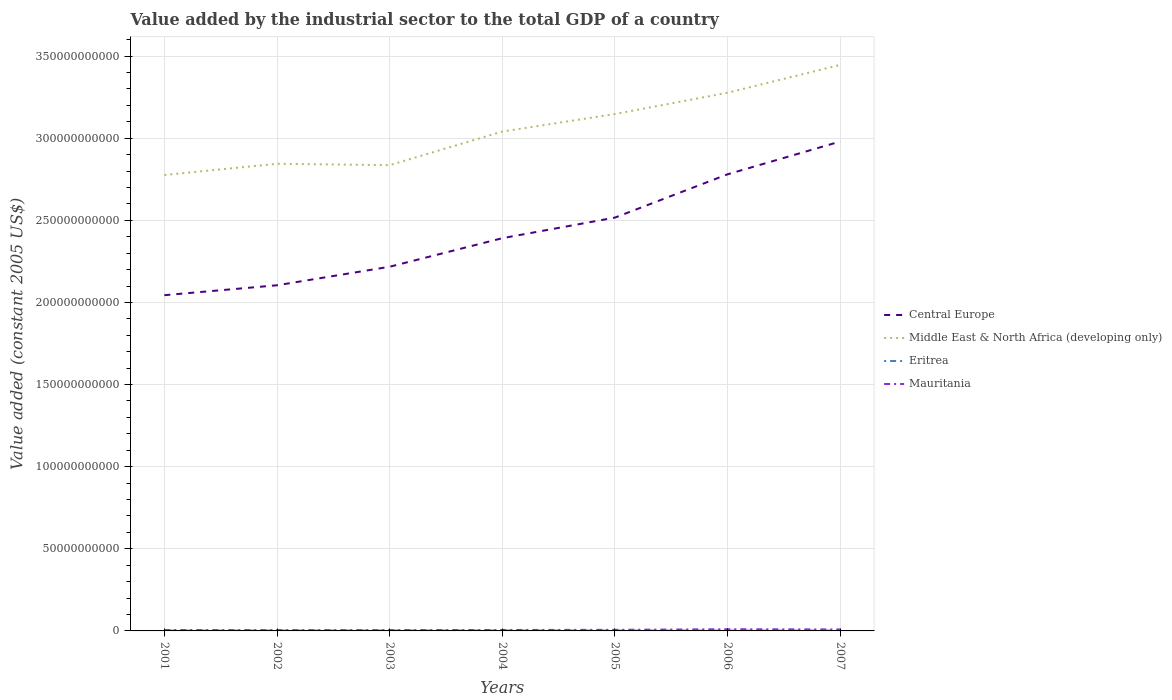Does the line corresponding to Middle East & North Africa (developing only) intersect with the line corresponding to Mauritania?
Offer a terse response. No. Across all years, what is the maximum value added by the industrial sector in Central Europe?
Your response must be concise. 2.04e+11. In which year was the value added by the industrial sector in Eritrea maximum?
Provide a short and direct response. 2001. What is the total value added by the industrial sector in Middle East & North Africa (developing only) in the graph?
Ensure brevity in your answer.  8.50e+08. What is the difference between the highest and the second highest value added by the industrial sector in Central Europe?
Give a very brief answer. 9.36e+1. What is the difference between the highest and the lowest value added by the industrial sector in Eritrea?
Ensure brevity in your answer.  3. How many years are there in the graph?
Ensure brevity in your answer.  7. Does the graph contain any zero values?
Offer a very short reply. No. Does the graph contain grids?
Ensure brevity in your answer.  Yes. How many legend labels are there?
Give a very brief answer. 4. How are the legend labels stacked?
Your answer should be very brief. Vertical. What is the title of the graph?
Offer a terse response. Value added by the industrial sector to the total GDP of a country. What is the label or title of the X-axis?
Your response must be concise. Years. What is the label or title of the Y-axis?
Your answer should be very brief. Value added (constant 2005 US$). What is the Value added (constant 2005 US$) of Central Europe in 2001?
Offer a terse response. 2.04e+11. What is the Value added (constant 2005 US$) of Middle East & North Africa (developing only) in 2001?
Provide a short and direct response. 2.78e+11. What is the Value added (constant 2005 US$) of Eritrea in 2001?
Keep it short and to the point. 1.92e+08. What is the Value added (constant 2005 US$) of Mauritania in 2001?
Provide a succinct answer. 5.36e+08. What is the Value added (constant 2005 US$) in Central Europe in 2002?
Provide a short and direct response. 2.10e+11. What is the Value added (constant 2005 US$) in Middle East & North Africa (developing only) in 2002?
Provide a succinct answer. 2.84e+11. What is the Value added (constant 2005 US$) in Eritrea in 2002?
Offer a terse response. 2.08e+08. What is the Value added (constant 2005 US$) in Mauritania in 2002?
Provide a short and direct response. 4.98e+08. What is the Value added (constant 2005 US$) of Central Europe in 2003?
Ensure brevity in your answer.  2.22e+11. What is the Value added (constant 2005 US$) in Middle East & North Africa (developing only) in 2003?
Your answer should be compact. 2.84e+11. What is the Value added (constant 2005 US$) in Eritrea in 2003?
Keep it short and to the point. 2.36e+08. What is the Value added (constant 2005 US$) in Mauritania in 2003?
Your answer should be compact. 5.08e+08. What is the Value added (constant 2005 US$) in Central Europe in 2004?
Provide a succinct answer. 2.39e+11. What is the Value added (constant 2005 US$) in Middle East & North Africa (developing only) in 2004?
Offer a very short reply. 3.04e+11. What is the Value added (constant 2005 US$) in Eritrea in 2004?
Keep it short and to the point. 2.47e+08. What is the Value added (constant 2005 US$) in Mauritania in 2004?
Provide a succinct answer. 5.74e+08. What is the Value added (constant 2005 US$) in Central Europe in 2005?
Offer a terse response. 2.52e+11. What is the Value added (constant 2005 US$) of Middle East & North Africa (developing only) in 2005?
Ensure brevity in your answer.  3.15e+11. What is the Value added (constant 2005 US$) of Eritrea in 2005?
Your answer should be very brief. 2.25e+08. What is the Value added (constant 2005 US$) in Mauritania in 2005?
Offer a very short reply. 6.69e+08. What is the Value added (constant 2005 US$) in Central Europe in 2006?
Make the answer very short. 2.78e+11. What is the Value added (constant 2005 US$) of Middle East & North Africa (developing only) in 2006?
Ensure brevity in your answer.  3.28e+11. What is the Value added (constant 2005 US$) of Eritrea in 2006?
Ensure brevity in your answer.  2.07e+08. What is the Value added (constant 2005 US$) of Mauritania in 2006?
Make the answer very short. 1.04e+09. What is the Value added (constant 2005 US$) of Central Europe in 2007?
Provide a succinct answer. 2.98e+11. What is the Value added (constant 2005 US$) of Middle East & North Africa (developing only) in 2007?
Make the answer very short. 3.45e+11. What is the Value added (constant 2005 US$) of Eritrea in 2007?
Provide a short and direct response. 2.11e+08. What is the Value added (constant 2005 US$) in Mauritania in 2007?
Make the answer very short. 9.11e+08. Across all years, what is the maximum Value added (constant 2005 US$) in Central Europe?
Keep it short and to the point. 2.98e+11. Across all years, what is the maximum Value added (constant 2005 US$) in Middle East & North Africa (developing only)?
Your answer should be compact. 3.45e+11. Across all years, what is the maximum Value added (constant 2005 US$) of Eritrea?
Provide a succinct answer. 2.47e+08. Across all years, what is the maximum Value added (constant 2005 US$) in Mauritania?
Offer a very short reply. 1.04e+09. Across all years, what is the minimum Value added (constant 2005 US$) of Central Europe?
Your response must be concise. 2.04e+11. Across all years, what is the minimum Value added (constant 2005 US$) in Middle East & North Africa (developing only)?
Offer a very short reply. 2.78e+11. Across all years, what is the minimum Value added (constant 2005 US$) of Eritrea?
Provide a succinct answer. 1.92e+08. Across all years, what is the minimum Value added (constant 2005 US$) of Mauritania?
Offer a very short reply. 4.98e+08. What is the total Value added (constant 2005 US$) of Central Europe in the graph?
Your answer should be very brief. 1.70e+12. What is the total Value added (constant 2005 US$) in Middle East & North Africa (developing only) in the graph?
Your response must be concise. 2.14e+12. What is the total Value added (constant 2005 US$) of Eritrea in the graph?
Your answer should be very brief. 1.53e+09. What is the total Value added (constant 2005 US$) of Mauritania in the graph?
Provide a succinct answer. 4.73e+09. What is the difference between the Value added (constant 2005 US$) in Central Europe in 2001 and that in 2002?
Keep it short and to the point. -6.04e+09. What is the difference between the Value added (constant 2005 US$) of Middle East & North Africa (developing only) in 2001 and that in 2002?
Make the answer very short. -6.81e+09. What is the difference between the Value added (constant 2005 US$) in Eritrea in 2001 and that in 2002?
Provide a succinct answer. -1.57e+07. What is the difference between the Value added (constant 2005 US$) of Mauritania in 2001 and that in 2002?
Your response must be concise. 3.79e+07. What is the difference between the Value added (constant 2005 US$) of Central Europe in 2001 and that in 2003?
Keep it short and to the point. -1.73e+1. What is the difference between the Value added (constant 2005 US$) in Middle East & North Africa (developing only) in 2001 and that in 2003?
Provide a short and direct response. -5.96e+09. What is the difference between the Value added (constant 2005 US$) in Eritrea in 2001 and that in 2003?
Your response must be concise. -4.41e+07. What is the difference between the Value added (constant 2005 US$) of Mauritania in 2001 and that in 2003?
Your answer should be compact. 2.74e+07. What is the difference between the Value added (constant 2005 US$) in Central Europe in 2001 and that in 2004?
Provide a short and direct response. -3.47e+1. What is the difference between the Value added (constant 2005 US$) of Middle East & North Africa (developing only) in 2001 and that in 2004?
Your answer should be compact. -2.64e+1. What is the difference between the Value added (constant 2005 US$) in Eritrea in 2001 and that in 2004?
Ensure brevity in your answer.  -5.49e+07. What is the difference between the Value added (constant 2005 US$) in Mauritania in 2001 and that in 2004?
Your answer should be very brief. -3.86e+07. What is the difference between the Value added (constant 2005 US$) of Central Europe in 2001 and that in 2005?
Offer a very short reply. -4.73e+1. What is the difference between the Value added (constant 2005 US$) in Middle East & North Africa (developing only) in 2001 and that in 2005?
Provide a succinct answer. -3.71e+1. What is the difference between the Value added (constant 2005 US$) of Eritrea in 2001 and that in 2005?
Your answer should be very brief. -3.26e+07. What is the difference between the Value added (constant 2005 US$) in Mauritania in 2001 and that in 2005?
Offer a very short reply. -1.34e+08. What is the difference between the Value added (constant 2005 US$) of Central Europe in 2001 and that in 2006?
Your response must be concise. -7.36e+1. What is the difference between the Value added (constant 2005 US$) in Middle East & North Africa (developing only) in 2001 and that in 2006?
Ensure brevity in your answer.  -5.01e+1. What is the difference between the Value added (constant 2005 US$) of Eritrea in 2001 and that in 2006?
Give a very brief answer. -1.49e+07. What is the difference between the Value added (constant 2005 US$) of Mauritania in 2001 and that in 2006?
Provide a succinct answer. -5.01e+08. What is the difference between the Value added (constant 2005 US$) of Central Europe in 2001 and that in 2007?
Your answer should be very brief. -9.36e+1. What is the difference between the Value added (constant 2005 US$) in Middle East & North Africa (developing only) in 2001 and that in 2007?
Offer a terse response. -6.70e+1. What is the difference between the Value added (constant 2005 US$) of Eritrea in 2001 and that in 2007?
Your answer should be compact. -1.85e+07. What is the difference between the Value added (constant 2005 US$) of Mauritania in 2001 and that in 2007?
Ensure brevity in your answer.  -3.76e+08. What is the difference between the Value added (constant 2005 US$) of Central Europe in 2002 and that in 2003?
Your answer should be very brief. -1.13e+1. What is the difference between the Value added (constant 2005 US$) of Middle East & North Africa (developing only) in 2002 and that in 2003?
Ensure brevity in your answer.  8.50e+08. What is the difference between the Value added (constant 2005 US$) of Eritrea in 2002 and that in 2003?
Offer a terse response. -2.83e+07. What is the difference between the Value added (constant 2005 US$) in Mauritania in 2002 and that in 2003?
Offer a terse response. -1.06e+07. What is the difference between the Value added (constant 2005 US$) of Central Europe in 2002 and that in 2004?
Your answer should be very brief. -2.87e+1. What is the difference between the Value added (constant 2005 US$) in Middle East & North Africa (developing only) in 2002 and that in 2004?
Make the answer very short. -1.96e+1. What is the difference between the Value added (constant 2005 US$) of Eritrea in 2002 and that in 2004?
Offer a very short reply. -3.91e+07. What is the difference between the Value added (constant 2005 US$) in Mauritania in 2002 and that in 2004?
Make the answer very short. -7.65e+07. What is the difference between the Value added (constant 2005 US$) in Central Europe in 2002 and that in 2005?
Offer a terse response. -4.12e+1. What is the difference between the Value added (constant 2005 US$) of Middle East & North Africa (developing only) in 2002 and that in 2005?
Your answer should be compact. -3.03e+1. What is the difference between the Value added (constant 2005 US$) in Eritrea in 2002 and that in 2005?
Give a very brief answer. -1.69e+07. What is the difference between the Value added (constant 2005 US$) of Mauritania in 2002 and that in 2005?
Make the answer very short. -1.72e+08. What is the difference between the Value added (constant 2005 US$) in Central Europe in 2002 and that in 2006?
Your answer should be very brief. -6.76e+1. What is the difference between the Value added (constant 2005 US$) of Middle East & North Africa (developing only) in 2002 and that in 2006?
Make the answer very short. -4.33e+1. What is the difference between the Value added (constant 2005 US$) of Eritrea in 2002 and that in 2006?
Ensure brevity in your answer.  8.30e+05. What is the difference between the Value added (constant 2005 US$) in Mauritania in 2002 and that in 2006?
Offer a very short reply. -5.39e+08. What is the difference between the Value added (constant 2005 US$) in Central Europe in 2002 and that in 2007?
Give a very brief answer. -8.76e+1. What is the difference between the Value added (constant 2005 US$) in Middle East & North Africa (developing only) in 2002 and that in 2007?
Provide a short and direct response. -6.02e+1. What is the difference between the Value added (constant 2005 US$) in Eritrea in 2002 and that in 2007?
Your answer should be very brief. -2.76e+06. What is the difference between the Value added (constant 2005 US$) of Mauritania in 2002 and that in 2007?
Ensure brevity in your answer.  -4.14e+08. What is the difference between the Value added (constant 2005 US$) in Central Europe in 2003 and that in 2004?
Give a very brief answer. -1.74e+1. What is the difference between the Value added (constant 2005 US$) in Middle East & North Africa (developing only) in 2003 and that in 2004?
Offer a very short reply. -2.05e+1. What is the difference between the Value added (constant 2005 US$) in Eritrea in 2003 and that in 2004?
Provide a succinct answer. -1.08e+07. What is the difference between the Value added (constant 2005 US$) in Mauritania in 2003 and that in 2004?
Offer a terse response. -6.59e+07. What is the difference between the Value added (constant 2005 US$) of Central Europe in 2003 and that in 2005?
Give a very brief answer. -2.99e+1. What is the difference between the Value added (constant 2005 US$) in Middle East & North Africa (developing only) in 2003 and that in 2005?
Offer a very short reply. -3.11e+1. What is the difference between the Value added (constant 2005 US$) of Eritrea in 2003 and that in 2005?
Provide a short and direct response. 1.14e+07. What is the difference between the Value added (constant 2005 US$) of Mauritania in 2003 and that in 2005?
Give a very brief answer. -1.61e+08. What is the difference between the Value added (constant 2005 US$) in Central Europe in 2003 and that in 2006?
Your response must be concise. -5.63e+1. What is the difference between the Value added (constant 2005 US$) in Middle East & North Africa (developing only) in 2003 and that in 2006?
Offer a very short reply. -4.41e+1. What is the difference between the Value added (constant 2005 US$) in Eritrea in 2003 and that in 2006?
Offer a terse response. 2.92e+07. What is the difference between the Value added (constant 2005 US$) of Mauritania in 2003 and that in 2006?
Your answer should be very brief. -5.29e+08. What is the difference between the Value added (constant 2005 US$) in Central Europe in 2003 and that in 2007?
Your answer should be very brief. -7.63e+1. What is the difference between the Value added (constant 2005 US$) of Middle East & North Africa (developing only) in 2003 and that in 2007?
Provide a succinct answer. -6.11e+1. What is the difference between the Value added (constant 2005 US$) of Eritrea in 2003 and that in 2007?
Your answer should be very brief. 2.56e+07. What is the difference between the Value added (constant 2005 US$) in Mauritania in 2003 and that in 2007?
Offer a very short reply. -4.03e+08. What is the difference between the Value added (constant 2005 US$) of Central Europe in 2004 and that in 2005?
Provide a succinct answer. -1.25e+1. What is the difference between the Value added (constant 2005 US$) of Middle East & North Africa (developing only) in 2004 and that in 2005?
Offer a terse response. -1.07e+1. What is the difference between the Value added (constant 2005 US$) in Eritrea in 2004 and that in 2005?
Your answer should be very brief. 2.22e+07. What is the difference between the Value added (constant 2005 US$) of Mauritania in 2004 and that in 2005?
Provide a succinct answer. -9.51e+07. What is the difference between the Value added (constant 2005 US$) of Central Europe in 2004 and that in 2006?
Give a very brief answer. -3.89e+1. What is the difference between the Value added (constant 2005 US$) in Middle East & North Africa (developing only) in 2004 and that in 2006?
Your answer should be very brief. -2.36e+1. What is the difference between the Value added (constant 2005 US$) in Eritrea in 2004 and that in 2006?
Provide a succinct answer. 4.00e+07. What is the difference between the Value added (constant 2005 US$) in Mauritania in 2004 and that in 2006?
Make the answer very short. -4.63e+08. What is the difference between the Value added (constant 2005 US$) in Central Europe in 2004 and that in 2007?
Your answer should be very brief. -5.89e+1. What is the difference between the Value added (constant 2005 US$) of Middle East & North Africa (developing only) in 2004 and that in 2007?
Offer a very short reply. -4.06e+1. What is the difference between the Value added (constant 2005 US$) of Eritrea in 2004 and that in 2007?
Offer a terse response. 3.64e+07. What is the difference between the Value added (constant 2005 US$) of Mauritania in 2004 and that in 2007?
Give a very brief answer. -3.37e+08. What is the difference between the Value added (constant 2005 US$) in Central Europe in 2005 and that in 2006?
Your answer should be very brief. -2.64e+1. What is the difference between the Value added (constant 2005 US$) in Middle East & North Africa (developing only) in 2005 and that in 2006?
Ensure brevity in your answer.  -1.30e+1. What is the difference between the Value added (constant 2005 US$) in Eritrea in 2005 and that in 2006?
Provide a succinct answer. 1.77e+07. What is the difference between the Value added (constant 2005 US$) of Mauritania in 2005 and that in 2006?
Your answer should be very brief. -3.68e+08. What is the difference between the Value added (constant 2005 US$) in Central Europe in 2005 and that in 2007?
Keep it short and to the point. -4.63e+1. What is the difference between the Value added (constant 2005 US$) of Middle East & North Africa (developing only) in 2005 and that in 2007?
Offer a very short reply. -2.99e+1. What is the difference between the Value added (constant 2005 US$) in Eritrea in 2005 and that in 2007?
Your response must be concise. 1.41e+07. What is the difference between the Value added (constant 2005 US$) in Mauritania in 2005 and that in 2007?
Keep it short and to the point. -2.42e+08. What is the difference between the Value added (constant 2005 US$) of Central Europe in 2006 and that in 2007?
Offer a terse response. -2.00e+1. What is the difference between the Value added (constant 2005 US$) in Middle East & North Africa (developing only) in 2006 and that in 2007?
Offer a very short reply. -1.70e+1. What is the difference between the Value added (constant 2005 US$) of Eritrea in 2006 and that in 2007?
Keep it short and to the point. -3.59e+06. What is the difference between the Value added (constant 2005 US$) of Mauritania in 2006 and that in 2007?
Keep it short and to the point. 1.26e+08. What is the difference between the Value added (constant 2005 US$) of Central Europe in 2001 and the Value added (constant 2005 US$) of Middle East & North Africa (developing only) in 2002?
Your answer should be very brief. -8.00e+1. What is the difference between the Value added (constant 2005 US$) in Central Europe in 2001 and the Value added (constant 2005 US$) in Eritrea in 2002?
Your answer should be very brief. 2.04e+11. What is the difference between the Value added (constant 2005 US$) of Central Europe in 2001 and the Value added (constant 2005 US$) of Mauritania in 2002?
Provide a short and direct response. 2.04e+11. What is the difference between the Value added (constant 2005 US$) in Middle East & North Africa (developing only) in 2001 and the Value added (constant 2005 US$) in Eritrea in 2002?
Give a very brief answer. 2.77e+11. What is the difference between the Value added (constant 2005 US$) of Middle East & North Africa (developing only) in 2001 and the Value added (constant 2005 US$) of Mauritania in 2002?
Make the answer very short. 2.77e+11. What is the difference between the Value added (constant 2005 US$) of Eritrea in 2001 and the Value added (constant 2005 US$) of Mauritania in 2002?
Your answer should be very brief. -3.05e+08. What is the difference between the Value added (constant 2005 US$) of Central Europe in 2001 and the Value added (constant 2005 US$) of Middle East & North Africa (developing only) in 2003?
Your answer should be compact. -7.92e+1. What is the difference between the Value added (constant 2005 US$) in Central Europe in 2001 and the Value added (constant 2005 US$) in Eritrea in 2003?
Provide a short and direct response. 2.04e+11. What is the difference between the Value added (constant 2005 US$) in Central Europe in 2001 and the Value added (constant 2005 US$) in Mauritania in 2003?
Provide a short and direct response. 2.04e+11. What is the difference between the Value added (constant 2005 US$) in Middle East & North Africa (developing only) in 2001 and the Value added (constant 2005 US$) in Eritrea in 2003?
Provide a succinct answer. 2.77e+11. What is the difference between the Value added (constant 2005 US$) in Middle East & North Africa (developing only) in 2001 and the Value added (constant 2005 US$) in Mauritania in 2003?
Provide a succinct answer. 2.77e+11. What is the difference between the Value added (constant 2005 US$) in Eritrea in 2001 and the Value added (constant 2005 US$) in Mauritania in 2003?
Offer a terse response. -3.16e+08. What is the difference between the Value added (constant 2005 US$) of Central Europe in 2001 and the Value added (constant 2005 US$) of Middle East & North Africa (developing only) in 2004?
Make the answer very short. -9.96e+1. What is the difference between the Value added (constant 2005 US$) in Central Europe in 2001 and the Value added (constant 2005 US$) in Eritrea in 2004?
Keep it short and to the point. 2.04e+11. What is the difference between the Value added (constant 2005 US$) of Central Europe in 2001 and the Value added (constant 2005 US$) of Mauritania in 2004?
Ensure brevity in your answer.  2.04e+11. What is the difference between the Value added (constant 2005 US$) of Middle East & North Africa (developing only) in 2001 and the Value added (constant 2005 US$) of Eritrea in 2004?
Your answer should be very brief. 2.77e+11. What is the difference between the Value added (constant 2005 US$) in Middle East & North Africa (developing only) in 2001 and the Value added (constant 2005 US$) in Mauritania in 2004?
Your response must be concise. 2.77e+11. What is the difference between the Value added (constant 2005 US$) in Eritrea in 2001 and the Value added (constant 2005 US$) in Mauritania in 2004?
Provide a succinct answer. -3.82e+08. What is the difference between the Value added (constant 2005 US$) of Central Europe in 2001 and the Value added (constant 2005 US$) of Middle East & North Africa (developing only) in 2005?
Ensure brevity in your answer.  -1.10e+11. What is the difference between the Value added (constant 2005 US$) of Central Europe in 2001 and the Value added (constant 2005 US$) of Eritrea in 2005?
Make the answer very short. 2.04e+11. What is the difference between the Value added (constant 2005 US$) in Central Europe in 2001 and the Value added (constant 2005 US$) in Mauritania in 2005?
Your response must be concise. 2.04e+11. What is the difference between the Value added (constant 2005 US$) of Middle East & North Africa (developing only) in 2001 and the Value added (constant 2005 US$) of Eritrea in 2005?
Provide a short and direct response. 2.77e+11. What is the difference between the Value added (constant 2005 US$) in Middle East & North Africa (developing only) in 2001 and the Value added (constant 2005 US$) in Mauritania in 2005?
Provide a short and direct response. 2.77e+11. What is the difference between the Value added (constant 2005 US$) in Eritrea in 2001 and the Value added (constant 2005 US$) in Mauritania in 2005?
Offer a terse response. -4.77e+08. What is the difference between the Value added (constant 2005 US$) of Central Europe in 2001 and the Value added (constant 2005 US$) of Middle East & North Africa (developing only) in 2006?
Give a very brief answer. -1.23e+11. What is the difference between the Value added (constant 2005 US$) of Central Europe in 2001 and the Value added (constant 2005 US$) of Eritrea in 2006?
Give a very brief answer. 2.04e+11. What is the difference between the Value added (constant 2005 US$) in Central Europe in 2001 and the Value added (constant 2005 US$) in Mauritania in 2006?
Offer a terse response. 2.03e+11. What is the difference between the Value added (constant 2005 US$) in Middle East & North Africa (developing only) in 2001 and the Value added (constant 2005 US$) in Eritrea in 2006?
Make the answer very short. 2.77e+11. What is the difference between the Value added (constant 2005 US$) of Middle East & North Africa (developing only) in 2001 and the Value added (constant 2005 US$) of Mauritania in 2006?
Ensure brevity in your answer.  2.77e+11. What is the difference between the Value added (constant 2005 US$) in Eritrea in 2001 and the Value added (constant 2005 US$) in Mauritania in 2006?
Provide a succinct answer. -8.45e+08. What is the difference between the Value added (constant 2005 US$) of Central Europe in 2001 and the Value added (constant 2005 US$) of Middle East & North Africa (developing only) in 2007?
Offer a very short reply. -1.40e+11. What is the difference between the Value added (constant 2005 US$) in Central Europe in 2001 and the Value added (constant 2005 US$) in Eritrea in 2007?
Keep it short and to the point. 2.04e+11. What is the difference between the Value added (constant 2005 US$) of Central Europe in 2001 and the Value added (constant 2005 US$) of Mauritania in 2007?
Provide a succinct answer. 2.04e+11. What is the difference between the Value added (constant 2005 US$) of Middle East & North Africa (developing only) in 2001 and the Value added (constant 2005 US$) of Eritrea in 2007?
Offer a terse response. 2.77e+11. What is the difference between the Value added (constant 2005 US$) in Middle East & North Africa (developing only) in 2001 and the Value added (constant 2005 US$) in Mauritania in 2007?
Ensure brevity in your answer.  2.77e+11. What is the difference between the Value added (constant 2005 US$) of Eritrea in 2001 and the Value added (constant 2005 US$) of Mauritania in 2007?
Your response must be concise. -7.19e+08. What is the difference between the Value added (constant 2005 US$) of Central Europe in 2002 and the Value added (constant 2005 US$) of Middle East & North Africa (developing only) in 2003?
Offer a terse response. -7.31e+1. What is the difference between the Value added (constant 2005 US$) in Central Europe in 2002 and the Value added (constant 2005 US$) in Eritrea in 2003?
Offer a very short reply. 2.10e+11. What is the difference between the Value added (constant 2005 US$) in Central Europe in 2002 and the Value added (constant 2005 US$) in Mauritania in 2003?
Provide a succinct answer. 2.10e+11. What is the difference between the Value added (constant 2005 US$) of Middle East & North Africa (developing only) in 2002 and the Value added (constant 2005 US$) of Eritrea in 2003?
Give a very brief answer. 2.84e+11. What is the difference between the Value added (constant 2005 US$) of Middle East & North Africa (developing only) in 2002 and the Value added (constant 2005 US$) of Mauritania in 2003?
Offer a terse response. 2.84e+11. What is the difference between the Value added (constant 2005 US$) in Eritrea in 2002 and the Value added (constant 2005 US$) in Mauritania in 2003?
Offer a very short reply. -3.00e+08. What is the difference between the Value added (constant 2005 US$) in Central Europe in 2002 and the Value added (constant 2005 US$) in Middle East & North Africa (developing only) in 2004?
Give a very brief answer. -9.36e+1. What is the difference between the Value added (constant 2005 US$) in Central Europe in 2002 and the Value added (constant 2005 US$) in Eritrea in 2004?
Your answer should be compact. 2.10e+11. What is the difference between the Value added (constant 2005 US$) in Central Europe in 2002 and the Value added (constant 2005 US$) in Mauritania in 2004?
Provide a succinct answer. 2.10e+11. What is the difference between the Value added (constant 2005 US$) in Middle East & North Africa (developing only) in 2002 and the Value added (constant 2005 US$) in Eritrea in 2004?
Give a very brief answer. 2.84e+11. What is the difference between the Value added (constant 2005 US$) of Middle East & North Africa (developing only) in 2002 and the Value added (constant 2005 US$) of Mauritania in 2004?
Offer a very short reply. 2.84e+11. What is the difference between the Value added (constant 2005 US$) in Eritrea in 2002 and the Value added (constant 2005 US$) in Mauritania in 2004?
Your answer should be compact. -3.66e+08. What is the difference between the Value added (constant 2005 US$) in Central Europe in 2002 and the Value added (constant 2005 US$) in Middle East & North Africa (developing only) in 2005?
Your answer should be compact. -1.04e+11. What is the difference between the Value added (constant 2005 US$) of Central Europe in 2002 and the Value added (constant 2005 US$) of Eritrea in 2005?
Your answer should be very brief. 2.10e+11. What is the difference between the Value added (constant 2005 US$) of Central Europe in 2002 and the Value added (constant 2005 US$) of Mauritania in 2005?
Your answer should be very brief. 2.10e+11. What is the difference between the Value added (constant 2005 US$) of Middle East & North Africa (developing only) in 2002 and the Value added (constant 2005 US$) of Eritrea in 2005?
Give a very brief answer. 2.84e+11. What is the difference between the Value added (constant 2005 US$) in Middle East & North Africa (developing only) in 2002 and the Value added (constant 2005 US$) in Mauritania in 2005?
Offer a terse response. 2.84e+11. What is the difference between the Value added (constant 2005 US$) of Eritrea in 2002 and the Value added (constant 2005 US$) of Mauritania in 2005?
Make the answer very short. -4.61e+08. What is the difference between the Value added (constant 2005 US$) of Central Europe in 2002 and the Value added (constant 2005 US$) of Middle East & North Africa (developing only) in 2006?
Provide a succinct answer. -1.17e+11. What is the difference between the Value added (constant 2005 US$) in Central Europe in 2002 and the Value added (constant 2005 US$) in Eritrea in 2006?
Keep it short and to the point. 2.10e+11. What is the difference between the Value added (constant 2005 US$) of Central Europe in 2002 and the Value added (constant 2005 US$) of Mauritania in 2006?
Provide a short and direct response. 2.09e+11. What is the difference between the Value added (constant 2005 US$) of Middle East & North Africa (developing only) in 2002 and the Value added (constant 2005 US$) of Eritrea in 2006?
Provide a short and direct response. 2.84e+11. What is the difference between the Value added (constant 2005 US$) of Middle East & North Africa (developing only) in 2002 and the Value added (constant 2005 US$) of Mauritania in 2006?
Offer a terse response. 2.83e+11. What is the difference between the Value added (constant 2005 US$) in Eritrea in 2002 and the Value added (constant 2005 US$) in Mauritania in 2006?
Offer a very short reply. -8.29e+08. What is the difference between the Value added (constant 2005 US$) of Central Europe in 2002 and the Value added (constant 2005 US$) of Middle East & North Africa (developing only) in 2007?
Offer a terse response. -1.34e+11. What is the difference between the Value added (constant 2005 US$) of Central Europe in 2002 and the Value added (constant 2005 US$) of Eritrea in 2007?
Make the answer very short. 2.10e+11. What is the difference between the Value added (constant 2005 US$) in Central Europe in 2002 and the Value added (constant 2005 US$) in Mauritania in 2007?
Ensure brevity in your answer.  2.10e+11. What is the difference between the Value added (constant 2005 US$) of Middle East & North Africa (developing only) in 2002 and the Value added (constant 2005 US$) of Eritrea in 2007?
Provide a short and direct response. 2.84e+11. What is the difference between the Value added (constant 2005 US$) in Middle East & North Africa (developing only) in 2002 and the Value added (constant 2005 US$) in Mauritania in 2007?
Provide a succinct answer. 2.84e+11. What is the difference between the Value added (constant 2005 US$) of Eritrea in 2002 and the Value added (constant 2005 US$) of Mauritania in 2007?
Provide a short and direct response. -7.03e+08. What is the difference between the Value added (constant 2005 US$) in Central Europe in 2003 and the Value added (constant 2005 US$) in Middle East & North Africa (developing only) in 2004?
Provide a succinct answer. -8.23e+1. What is the difference between the Value added (constant 2005 US$) in Central Europe in 2003 and the Value added (constant 2005 US$) in Eritrea in 2004?
Provide a succinct answer. 2.21e+11. What is the difference between the Value added (constant 2005 US$) of Central Europe in 2003 and the Value added (constant 2005 US$) of Mauritania in 2004?
Ensure brevity in your answer.  2.21e+11. What is the difference between the Value added (constant 2005 US$) of Middle East & North Africa (developing only) in 2003 and the Value added (constant 2005 US$) of Eritrea in 2004?
Keep it short and to the point. 2.83e+11. What is the difference between the Value added (constant 2005 US$) of Middle East & North Africa (developing only) in 2003 and the Value added (constant 2005 US$) of Mauritania in 2004?
Give a very brief answer. 2.83e+11. What is the difference between the Value added (constant 2005 US$) in Eritrea in 2003 and the Value added (constant 2005 US$) in Mauritania in 2004?
Keep it short and to the point. -3.38e+08. What is the difference between the Value added (constant 2005 US$) in Central Europe in 2003 and the Value added (constant 2005 US$) in Middle East & North Africa (developing only) in 2005?
Make the answer very short. -9.30e+1. What is the difference between the Value added (constant 2005 US$) of Central Europe in 2003 and the Value added (constant 2005 US$) of Eritrea in 2005?
Offer a terse response. 2.22e+11. What is the difference between the Value added (constant 2005 US$) in Central Europe in 2003 and the Value added (constant 2005 US$) in Mauritania in 2005?
Your response must be concise. 2.21e+11. What is the difference between the Value added (constant 2005 US$) in Middle East & North Africa (developing only) in 2003 and the Value added (constant 2005 US$) in Eritrea in 2005?
Provide a succinct answer. 2.83e+11. What is the difference between the Value added (constant 2005 US$) of Middle East & North Africa (developing only) in 2003 and the Value added (constant 2005 US$) of Mauritania in 2005?
Offer a very short reply. 2.83e+11. What is the difference between the Value added (constant 2005 US$) of Eritrea in 2003 and the Value added (constant 2005 US$) of Mauritania in 2005?
Make the answer very short. -4.33e+08. What is the difference between the Value added (constant 2005 US$) of Central Europe in 2003 and the Value added (constant 2005 US$) of Middle East & North Africa (developing only) in 2006?
Your answer should be compact. -1.06e+11. What is the difference between the Value added (constant 2005 US$) in Central Europe in 2003 and the Value added (constant 2005 US$) in Eritrea in 2006?
Ensure brevity in your answer.  2.22e+11. What is the difference between the Value added (constant 2005 US$) in Central Europe in 2003 and the Value added (constant 2005 US$) in Mauritania in 2006?
Provide a succinct answer. 2.21e+11. What is the difference between the Value added (constant 2005 US$) of Middle East & North Africa (developing only) in 2003 and the Value added (constant 2005 US$) of Eritrea in 2006?
Your answer should be compact. 2.83e+11. What is the difference between the Value added (constant 2005 US$) in Middle East & North Africa (developing only) in 2003 and the Value added (constant 2005 US$) in Mauritania in 2006?
Make the answer very short. 2.83e+11. What is the difference between the Value added (constant 2005 US$) of Eritrea in 2003 and the Value added (constant 2005 US$) of Mauritania in 2006?
Offer a terse response. -8.01e+08. What is the difference between the Value added (constant 2005 US$) of Central Europe in 2003 and the Value added (constant 2005 US$) of Middle East & North Africa (developing only) in 2007?
Make the answer very short. -1.23e+11. What is the difference between the Value added (constant 2005 US$) of Central Europe in 2003 and the Value added (constant 2005 US$) of Eritrea in 2007?
Offer a terse response. 2.22e+11. What is the difference between the Value added (constant 2005 US$) in Central Europe in 2003 and the Value added (constant 2005 US$) in Mauritania in 2007?
Your response must be concise. 2.21e+11. What is the difference between the Value added (constant 2005 US$) in Middle East & North Africa (developing only) in 2003 and the Value added (constant 2005 US$) in Eritrea in 2007?
Give a very brief answer. 2.83e+11. What is the difference between the Value added (constant 2005 US$) of Middle East & North Africa (developing only) in 2003 and the Value added (constant 2005 US$) of Mauritania in 2007?
Your answer should be compact. 2.83e+11. What is the difference between the Value added (constant 2005 US$) in Eritrea in 2003 and the Value added (constant 2005 US$) in Mauritania in 2007?
Provide a succinct answer. -6.75e+08. What is the difference between the Value added (constant 2005 US$) in Central Europe in 2004 and the Value added (constant 2005 US$) in Middle East & North Africa (developing only) in 2005?
Keep it short and to the point. -7.56e+1. What is the difference between the Value added (constant 2005 US$) in Central Europe in 2004 and the Value added (constant 2005 US$) in Eritrea in 2005?
Your answer should be very brief. 2.39e+11. What is the difference between the Value added (constant 2005 US$) in Central Europe in 2004 and the Value added (constant 2005 US$) in Mauritania in 2005?
Keep it short and to the point. 2.38e+11. What is the difference between the Value added (constant 2005 US$) in Middle East & North Africa (developing only) in 2004 and the Value added (constant 2005 US$) in Eritrea in 2005?
Offer a very short reply. 3.04e+11. What is the difference between the Value added (constant 2005 US$) in Middle East & North Africa (developing only) in 2004 and the Value added (constant 2005 US$) in Mauritania in 2005?
Offer a very short reply. 3.03e+11. What is the difference between the Value added (constant 2005 US$) of Eritrea in 2004 and the Value added (constant 2005 US$) of Mauritania in 2005?
Offer a very short reply. -4.22e+08. What is the difference between the Value added (constant 2005 US$) in Central Europe in 2004 and the Value added (constant 2005 US$) in Middle East & North Africa (developing only) in 2006?
Your answer should be very brief. -8.86e+1. What is the difference between the Value added (constant 2005 US$) in Central Europe in 2004 and the Value added (constant 2005 US$) in Eritrea in 2006?
Your response must be concise. 2.39e+11. What is the difference between the Value added (constant 2005 US$) of Central Europe in 2004 and the Value added (constant 2005 US$) of Mauritania in 2006?
Provide a short and direct response. 2.38e+11. What is the difference between the Value added (constant 2005 US$) of Middle East & North Africa (developing only) in 2004 and the Value added (constant 2005 US$) of Eritrea in 2006?
Provide a succinct answer. 3.04e+11. What is the difference between the Value added (constant 2005 US$) in Middle East & North Africa (developing only) in 2004 and the Value added (constant 2005 US$) in Mauritania in 2006?
Your answer should be compact. 3.03e+11. What is the difference between the Value added (constant 2005 US$) of Eritrea in 2004 and the Value added (constant 2005 US$) of Mauritania in 2006?
Make the answer very short. -7.90e+08. What is the difference between the Value added (constant 2005 US$) of Central Europe in 2004 and the Value added (constant 2005 US$) of Middle East & North Africa (developing only) in 2007?
Ensure brevity in your answer.  -1.06e+11. What is the difference between the Value added (constant 2005 US$) of Central Europe in 2004 and the Value added (constant 2005 US$) of Eritrea in 2007?
Your answer should be very brief. 2.39e+11. What is the difference between the Value added (constant 2005 US$) of Central Europe in 2004 and the Value added (constant 2005 US$) of Mauritania in 2007?
Keep it short and to the point. 2.38e+11. What is the difference between the Value added (constant 2005 US$) of Middle East & North Africa (developing only) in 2004 and the Value added (constant 2005 US$) of Eritrea in 2007?
Ensure brevity in your answer.  3.04e+11. What is the difference between the Value added (constant 2005 US$) in Middle East & North Africa (developing only) in 2004 and the Value added (constant 2005 US$) in Mauritania in 2007?
Ensure brevity in your answer.  3.03e+11. What is the difference between the Value added (constant 2005 US$) of Eritrea in 2004 and the Value added (constant 2005 US$) of Mauritania in 2007?
Your answer should be compact. -6.64e+08. What is the difference between the Value added (constant 2005 US$) of Central Europe in 2005 and the Value added (constant 2005 US$) of Middle East & North Africa (developing only) in 2006?
Your response must be concise. -7.60e+1. What is the difference between the Value added (constant 2005 US$) in Central Europe in 2005 and the Value added (constant 2005 US$) in Eritrea in 2006?
Provide a succinct answer. 2.51e+11. What is the difference between the Value added (constant 2005 US$) of Central Europe in 2005 and the Value added (constant 2005 US$) of Mauritania in 2006?
Your answer should be very brief. 2.51e+11. What is the difference between the Value added (constant 2005 US$) in Middle East & North Africa (developing only) in 2005 and the Value added (constant 2005 US$) in Eritrea in 2006?
Provide a short and direct response. 3.15e+11. What is the difference between the Value added (constant 2005 US$) of Middle East & North Africa (developing only) in 2005 and the Value added (constant 2005 US$) of Mauritania in 2006?
Your answer should be compact. 3.14e+11. What is the difference between the Value added (constant 2005 US$) of Eritrea in 2005 and the Value added (constant 2005 US$) of Mauritania in 2006?
Your answer should be compact. -8.12e+08. What is the difference between the Value added (constant 2005 US$) in Central Europe in 2005 and the Value added (constant 2005 US$) in Middle East & North Africa (developing only) in 2007?
Keep it short and to the point. -9.30e+1. What is the difference between the Value added (constant 2005 US$) in Central Europe in 2005 and the Value added (constant 2005 US$) in Eritrea in 2007?
Ensure brevity in your answer.  2.51e+11. What is the difference between the Value added (constant 2005 US$) of Central Europe in 2005 and the Value added (constant 2005 US$) of Mauritania in 2007?
Provide a succinct answer. 2.51e+11. What is the difference between the Value added (constant 2005 US$) of Middle East & North Africa (developing only) in 2005 and the Value added (constant 2005 US$) of Eritrea in 2007?
Make the answer very short. 3.15e+11. What is the difference between the Value added (constant 2005 US$) in Middle East & North Africa (developing only) in 2005 and the Value added (constant 2005 US$) in Mauritania in 2007?
Your answer should be very brief. 3.14e+11. What is the difference between the Value added (constant 2005 US$) of Eritrea in 2005 and the Value added (constant 2005 US$) of Mauritania in 2007?
Give a very brief answer. -6.86e+08. What is the difference between the Value added (constant 2005 US$) in Central Europe in 2006 and the Value added (constant 2005 US$) in Middle East & North Africa (developing only) in 2007?
Give a very brief answer. -6.66e+1. What is the difference between the Value added (constant 2005 US$) of Central Europe in 2006 and the Value added (constant 2005 US$) of Eritrea in 2007?
Your answer should be compact. 2.78e+11. What is the difference between the Value added (constant 2005 US$) in Central Europe in 2006 and the Value added (constant 2005 US$) in Mauritania in 2007?
Make the answer very short. 2.77e+11. What is the difference between the Value added (constant 2005 US$) in Middle East & North Africa (developing only) in 2006 and the Value added (constant 2005 US$) in Eritrea in 2007?
Give a very brief answer. 3.27e+11. What is the difference between the Value added (constant 2005 US$) of Middle East & North Africa (developing only) in 2006 and the Value added (constant 2005 US$) of Mauritania in 2007?
Ensure brevity in your answer.  3.27e+11. What is the difference between the Value added (constant 2005 US$) of Eritrea in 2006 and the Value added (constant 2005 US$) of Mauritania in 2007?
Keep it short and to the point. -7.04e+08. What is the average Value added (constant 2005 US$) in Central Europe per year?
Offer a very short reply. 2.43e+11. What is the average Value added (constant 2005 US$) of Middle East & North Africa (developing only) per year?
Your answer should be very brief. 3.05e+11. What is the average Value added (constant 2005 US$) of Eritrea per year?
Keep it short and to the point. 2.18e+08. What is the average Value added (constant 2005 US$) in Mauritania per year?
Provide a succinct answer. 6.76e+08. In the year 2001, what is the difference between the Value added (constant 2005 US$) in Central Europe and Value added (constant 2005 US$) in Middle East & North Africa (developing only)?
Give a very brief answer. -7.32e+1. In the year 2001, what is the difference between the Value added (constant 2005 US$) of Central Europe and Value added (constant 2005 US$) of Eritrea?
Your answer should be compact. 2.04e+11. In the year 2001, what is the difference between the Value added (constant 2005 US$) in Central Europe and Value added (constant 2005 US$) in Mauritania?
Your answer should be compact. 2.04e+11. In the year 2001, what is the difference between the Value added (constant 2005 US$) in Middle East & North Africa (developing only) and Value added (constant 2005 US$) in Eritrea?
Provide a succinct answer. 2.77e+11. In the year 2001, what is the difference between the Value added (constant 2005 US$) of Middle East & North Africa (developing only) and Value added (constant 2005 US$) of Mauritania?
Offer a very short reply. 2.77e+11. In the year 2001, what is the difference between the Value added (constant 2005 US$) in Eritrea and Value added (constant 2005 US$) in Mauritania?
Provide a succinct answer. -3.43e+08. In the year 2002, what is the difference between the Value added (constant 2005 US$) in Central Europe and Value added (constant 2005 US$) in Middle East & North Africa (developing only)?
Your response must be concise. -7.40e+1. In the year 2002, what is the difference between the Value added (constant 2005 US$) in Central Europe and Value added (constant 2005 US$) in Eritrea?
Offer a terse response. 2.10e+11. In the year 2002, what is the difference between the Value added (constant 2005 US$) in Central Europe and Value added (constant 2005 US$) in Mauritania?
Your answer should be very brief. 2.10e+11. In the year 2002, what is the difference between the Value added (constant 2005 US$) in Middle East & North Africa (developing only) and Value added (constant 2005 US$) in Eritrea?
Your answer should be compact. 2.84e+11. In the year 2002, what is the difference between the Value added (constant 2005 US$) of Middle East & North Africa (developing only) and Value added (constant 2005 US$) of Mauritania?
Provide a short and direct response. 2.84e+11. In the year 2002, what is the difference between the Value added (constant 2005 US$) in Eritrea and Value added (constant 2005 US$) in Mauritania?
Make the answer very short. -2.90e+08. In the year 2003, what is the difference between the Value added (constant 2005 US$) of Central Europe and Value added (constant 2005 US$) of Middle East & North Africa (developing only)?
Offer a terse response. -6.18e+1. In the year 2003, what is the difference between the Value added (constant 2005 US$) in Central Europe and Value added (constant 2005 US$) in Eritrea?
Your answer should be very brief. 2.22e+11. In the year 2003, what is the difference between the Value added (constant 2005 US$) in Central Europe and Value added (constant 2005 US$) in Mauritania?
Your answer should be very brief. 2.21e+11. In the year 2003, what is the difference between the Value added (constant 2005 US$) in Middle East & North Africa (developing only) and Value added (constant 2005 US$) in Eritrea?
Your response must be concise. 2.83e+11. In the year 2003, what is the difference between the Value added (constant 2005 US$) in Middle East & North Africa (developing only) and Value added (constant 2005 US$) in Mauritania?
Give a very brief answer. 2.83e+11. In the year 2003, what is the difference between the Value added (constant 2005 US$) of Eritrea and Value added (constant 2005 US$) of Mauritania?
Offer a terse response. -2.72e+08. In the year 2004, what is the difference between the Value added (constant 2005 US$) of Central Europe and Value added (constant 2005 US$) of Middle East & North Africa (developing only)?
Give a very brief answer. -6.49e+1. In the year 2004, what is the difference between the Value added (constant 2005 US$) of Central Europe and Value added (constant 2005 US$) of Eritrea?
Give a very brief answer. 2.39e+11. In the year 2004, what is the difference between the Value added (constant 2005 US$) of Central Europe and Value added (constant 2005 US$) of Mauritania?
Offer a very short reply. 2.39e+11. In the year 2004, what is the difference between the Value added (constant 2005 US$) of Middle East & North Africa (developing only) and Value added (constant 2005 US$) of Eritrea?
Provide a succinct answer. 3.04e+11. In the year 2004, what is the difference between the Value added (constant 2005 US$) in Middle East & North Africa (developing only) and Value added (constant 2005 US$) in Mauritania?
Keep it short and to the point. 3.03e+11. In the year 2004, what is the difference between the Value added (constant 2005 US$) of Eritrea and Value added (constant 2005 US$) of Mauritania?
Offer a terse response. -3.27e+08. In the year 2005, what is the difference between the Value added (constant 2005 US$) in Central Europe and Value added (constant 2005 US$) in Middle East & North Africa (developing only)?
Keep it short and to the point. -6.31e+1. In the year 2005, what is the difference between the Value added (constant 2005 US$) in Central Europe and Value added (constant 2005 US$) in Eritrea?
Your response must be concise. 2.51e+11. In the year 2005, what is the difference between the Value added (constant 2005 US$) in Central Europe and Value added (constant 2005 US$) in Mauritania?
Your response must be concise. 2.51e+11. In the year 2005, what is the difference between the Value added (constant 2005 US$) in Middle East & North Africa (developing only) and Value added (constant 2005 US$) in Eritrea?
Provide a succinct answer. 3.14e+11. In the year 2005, what is the difference between the Value added (constant 2005 US$) in Middle East & North Africa (developing only) and Value added (constant 2005 US$) in Mauritania?
Offer a very short reply. 3.14e+11. In the year 2005, what is the difference between the Value added (constant 2005 US$) of Eritrea and Value added (constant 2005 US$) of Mauritania?
Your answer should be very brief. -4.44e+08. In the year 2006, what is the difference between the Value added (constant 2005 US$) of Central Europe and Value added (constant 2005 US$) of Middle East & North Africa (developing only)?
Provide a succinct answer. -4.97e+1. In the year 2006, what is the difference between the Value added (constant 2005 US$) of Central Europe and Value added (constant 2005 US$) of Eritrea?
Your answer should be very brief. 2.78e+11. In the year 2006, what is the difference between the Value added (constant 2005 US$) in Central Europe and Value added (constant 2005 US$) in Mauritania?
Your response must be concise. 2.77e+11. In the year 2006, what is the difference between the Value added (constant 2005 US$) of Middle East & North Africa (developing only) and Value added (constant 2005 US$) of Eritrea?
Keep it short and to the point. 3.27e+11. In the year 2006, what is the difference between the Value added (constant 2005 US$) of Middle East & North Africa (developing only) and Value added (constant 2005 US$) of Mauritania?
Give a very brief answer. 3.27e+11. In the year 2006, what is the difference between the Value added (constant 2005 US$) of Eritrea and Value added (constant 2005 US$) of Mauritania?
Offer a terse response. -8.30e+08. In the year 2007, what is the difference between the Value added (constant 2005 US$) in Central Europe and Value added (constant 2005 US$) in Middle East & North Africa (developing only)?
Give a very brief answer. -4.66e+1. In the year 2007, what is the difference between the Value added (constant 2005 US$) of Central Europe and Value added (constant 2005 US$) of Eritrea?
Your answer should be compact. 2.98e+11. In the year 2007, what is the difference between the Value added (constant 2005 US$) of Central Europe and Value added (constant 2005 US$) of Mauritania?
Give a very brief answer. 2.97e+11. In the year 2007, what is the difference between the Value added (constant 2005 US$) in Middle East & North Africa (developing only) and Value added (constant 2005 US$) in Eritrea?
Provide a short and direct response. 3.44e+11. In the year 2007, what is the difference between the Value added (constant 2005 US$) of Middle East & North Africa (developing only) and Value added (constant 2005 US$) of Mauritania?
Make the answer very short. 3.44e+11. In the year 2007, what is the difference between the Value added (constant 2005 US$) of Eritrea and Value added (constant 2005 US$) of Mauritania?
Keep it short and to the point. -7.01e+08. What is the ratio of the Value added (constant 2005 US$) of Central Europe in 2001 to that in 2002?
Provide a short and direct response. 0.97. What is the ratio of the Value added (constant 2005 US$) of Middle East & North Africa (developing only) in 2001 to that in 2002?
Offer a very short reply. 0.98. What is the ratio of the Value added (constant 2005 US$) in Eritrea in 2001 to that in 2002?
Your response must be concise. 0.92. What is the ratio of the Value added (constant 2005 US$) in Mauritania in 2001 to that in 2002?
Make the answer very short. 1.08. What is the ratio of the Value added (constant 2005 US$) in Central Europe in 2001 to that in 2003?
Provide a short and direct response. 0.92. What is the ratio of the Value added (constant 2005 US$) of Middle East & North Africa (developing only) in 2001 to that in 2003?
Provide a succinct answer. 0.98. What is the ratio of the Value added (constant 2005 US$) of Eritrea in 2001 to that in 2003?
Keep it short and to the point. 0.81. What is the ratio of the Value added (constant 2005 US$) in Mauritania in 2001 to that in 2003?
Offer a terse response. 1.05. What is the ratio of the Value added (constant 2005 US$) of Central Europe in 2001 to that in 2004?
Ensure brevity in your answer.  0.85. What is the ratio of the Value added (constant 2005 US$) of Eritrea in 2001 to that in 2004?
Provide a succinct answer. 0.78. What is the ratio of the Value added (constant 2005 US$) of Mauritania in 2001 to that in 2004?
Your response must be concise. 0.93. What is the ratio of the Value added (constant 2005 US$) of Central Europe in 2001 to that in 2005?
Ensure brevity in your answer.  0.81. What is the ratio of the Value added (constant 2005 US$) of Middle East & North Africa (developing only) in 2001 to that in 2005?
Provide a succinct answer. 0.88. What is the ratio of the Value added (constant 2005 US$) in Eritrea in 2001 to that in 2005?
Keep it short and to the point. 0.85. What is the ratio of the Value added (constant 2005 US$) of Mauritania in 2001 to that in 2005?
Provide a short and direct response. 0.8. What is the ratio of the Value added (constant 2005 US$) of Central Europe in 2001 to that in 2006?
Offer a terse response. 0.74. What is the ratio of the Value added (constant 2005 US$) in Middle East & North Africa (developing only) in 2001 to that in 2006?
Your answer should be compact. 0.85. What is the ratio of the Value added (constant 2005 US$) of Eritrea in 2001 to that in 2006?
Offer a terse response. 0.93. What is the ratio of the Value added (constant 2005 US$) of Mauritania in 2001 to that in 2006?
Ensure brevity in your answer.  0.52. What is the ratio of the Value added (constant 2005 US$) in Central Europe in 2001 to that in 2007?
Provide a short and direct response. 0.69. What is the ratio of the Value added (constant 2005 US$) of Middle East & North Africa (developing only) in 2001 to that in 2007?
Your answer should be very brief. 0.81. What is the ratio of the Value added (constant 2005 US$) of Eritrea in 2001 to that in 2007?
Keep it short and to the point. 0.91. What is the ratio of the Value added (constant 2005 US$) in Mauritania in 2001 to that in 2007?
Provide a short and direct response. 0.59. What is the ratio of the Value added (constant 2005 US$) of Central Europe in 2002 to that in 2003?
Give a very brief answer. 0.95. What is the ratio of the Value added (constant 2005 US$) in Eritrea in 2002 to that in 2003?
Ensure brevity in your answer.  0.88. What is the ratio of the Value added (constant 2005 US$) of Mauritania in 2002 to that in 2003?
Your answer should be very brief. 0.98. What is the ratio of the Value added (constant 2005 US$) of Central Europe in 2002 to that in 2004?
Provide a succinct answer. 0.88. What is the ratio of the Value added (constant 2005 US$) in Middle East & North Africa (developing only) in 2002 to that in 2004?
Provide a succinct answer. 0.94. What is the ratio of the Value added (constant 2005 US$) of Eritrea in 2002 to that in 2004?
Offer a terse response. 0.84. What is the ratio of the Value added (constant 2005 US$) in Mauritania in 2002 to that in 2004?
Offer a terse response. 0.87. What is the ratio of the Value added (constant 2005 US$) of Central Europe in 2002 to that in 2005?
Offer a very short reply. 0.84. What is the ratio of the Value added (constant 2005 US$) in Middle East & North Africa (developing only) in 2002 to that in 2005?
Your answer should be very brief. 0.9. What is the ratio of the Value added (constant 2005 US$) of Eritrea in 2002 to that in 2005?
Offer a terse response. 0.92. What is the ratio of the Value added (constant 2005 US$) of Mauritania in 2002 to that in 2005?
Offer a terse response. 0.74. What is the ratio of the Value added (constant 2005 US$) of Central Europe in 2002 to that in 2006?
Your answer should be very brief. 0.76. What is the ratio of the Value added (constant 2005 US$) of Middle East & North Africa (developing only) in 2002 to that in 2006?
Provide a succinct answer. 0.87. What is the ratio of the Value added (constant 2005 US$) in Mauritania in 2002 to that in 2006?
Make the answer very short. 0.48. What is the ratio of the Value added (constant 2005 US$) in Central Europe in 2002 to that in 2007?
Offer a very short reply. 0.71. What is the ratio of the Value added (constant 2005 US$) of Middle East & North Africa (developing only) in 2002 to that in 2007?
Provide a short and direct response. 0.83. What is the ratio of the Value added (constant 2005 US$) in Eritrea in 2002 to that in 2007?
Offer a very short reply. 0.99. What is the ratio of the Value added (constant 2005 US$) in Mauritania in 2002 to that in 2007?
Your response must be concise. 0.55. What is the ratio of the Value added (constant 2005 US$) of Central Europe in 2003 to that in 2004?
Your response must be concise. 0.93. What is the ratio of the Value added (constant 2005 US$) in Middle East & North Africa (developing only) in 2003 to that in 2004?
Offer a very short reply. 0.93. What is the ratio of the Value added (constant 2005 US$) of Eritrea in 2003 to that in 2004?
Provide a succinct answer. 0.96. What is the ratio of the Value added (constant 2005 US$) of Mauritania in 2003 to that in 2004?
Offer a terse response. 0.89. What is the ratio of the Value added (constant 2005 US$) of Central Europe in 2003 to that in 2005?
Ensure brevity in your answer.  0.88. What is the ratio of the Value added (constant 2005 US$) in Middle East & North Africa (developing only) in 2003 to that in 2005?
Keep it short and to the point. 0.9. What is the ratio of the Value added (constant 2005 US$) of Eritrea in 2003 to that in 2005?
Give a very brief answer. 1.05. What is the ratio of the Value added (constant 2005 US$) of Mauritania in 2003 to that in 2005?
Keep it short and to the point. 0.76. What is the ratio of the Value added (constant 2005 US$) of Central Europe in 2003 to that in 2006?
Offer a very short reply. 0.8. What is the ratio of the Value added (constant 2005 US$) of Middle East & North Africa (developing only) in 2003 to that in 2006?
Ensure brevity in your answer.  0.87. What is the ratio of the Value added (constant 2005 US$) in Eritrea in 2003 to that in 2006?
Your answer should be very brief. 1.14. What is the ratio of the Value added (constant 2005 US$) of Mauritania in 2003 to that in 2006?
Make the answer very short. 0.49. What is the ratio of the Value added (constant 2005 US$) of Central Europe in 2003 to that in 2007?
Offer a very short reply. 0.74. What is the ratio of the Value added (constant 2005 US$) of Middle East & North Africa (developing only) in 2003 to that in 2007?
Your answer should be very brief. 0.82. What is the ratio of the Value added (constant 2005 US$) in Eritrea in 2003 to that in 2007?
Give a very brief answer. 1.12. What is the ratio of the Value added (constant 2005 US$) in Mauritania in 2003 to that in 2007?
Your response must be concise. 0.56. What is the ratio of the Value added (constant 2005 US$) in Central Europe in 2004 to that in 2005?
Your answer should be very brief. 0.95. What is the ratio of the Value added (constant 2005 US$) in Middle East & North Africa (developing only) in 2004 to that in 2005?
Your response must be concise. 0.97. What is the ratio of the Value added (constant 2005 US$) in Eritrea in 2004 to that in 2005?
Your answer should be very brief. 1.1. What is the ratio of the Value added (constant 2005 US$) in Mauritania in 2004 to that in 2005?
Your answer should be very brief. 0.86. What is the ratio of the Value added (constant 2005 US$) of Central Europe in 2004 to that in 2006?
Provide a short and direct response. 0.86. What is the ratio of the Value added (constant 2005 US$) of Middle East & North Africa (developing only) in 2004 to that in 2006?
Give a very brief answer. 0.93. What is the ratio of the Value added (constant 2005 US$) of Eritrea in 2004 to that in 2006?
Offer a terse response. 1.19. What is the ratio of the Value added (constant 2005 US$) in Mauritania in 2004 to that in 2006?
Offer a very short reply. 0.55. What is the ratio of the Value added (constant 2005 US$) of Central Europe in 2004 to that in 2007?
Provide a short and direct response. 0.8. What is the ratio of the Value added (constant 2005 US$) of Middle East & North Africa (developing only) in 2004 to that in 2007?
Your answer should be compact. 0.88. What is the ratio of the Value added (constant 2005 US$) of Eritrea in 2004 to that in 2007?
Keep it short and to the point. 1.17. What is the ratio of the Value added (constant 2005 US$) of Mauritania in 2004 to that in 2007?
Give a very brief answer. 0.63. What is the ratio of the Value added (constant 2005 US$) in Central Europe in 2005 to that in 2006?
Keep it short and to the point. 0.91. What is the ratio of the Value added (constant 2005 US$) of Middle East & North Africa (developing only) in 2005 to that in 2006?
Provide a short and direct response. 0.96. What is the ratio of the Value added (constant 2005 US$) of Eritrea in 2005 to that in 2006?
Keep it short and to the point. 1.09. What is the ratio of the Value added (constant 2005 US$) in Mauritania in 2005 to that in 2006?
Your answer should be very brief. 0.65. What is the ratio of the Value added (constant 2005 US$) of Central Europe in 2005 to that in 2007?
Keep it short and to the point. 0.84. What is the ratio of the Value added (constant 2005 US$) in Middle East & North Africa (developing only) in 2005 to that in 2007?
Offer a terse response. 0.91. What is the ratio of the Value added (constant 2005 US$) in Eritrea in 2005 to that in 2007?
Make the answer very short. 1.07. What is the ratio of the Value added (constant 2005 US$) of Mauritania in 2005 to that in 2007?
Ensure brevity in your answer.  0.73. What is the ratio of the Value added (constant 2005 US$) of Central Europe in 2006 to that in 2007?
Offer a very short reply. 0.93. What is the ratio of the Value added (constant 2005 US$) in Middle East & North Africa (developing only) in 2006 to that in 2007?
Your answer should be compact. 0.95. What is the ratio of the Value added (constant 2005 US$) in Eritrea in 2006 to that in 2007?
Your answer should be compact. 0.98. What is the ratio of the Value added (constant 2005 US$) of Mauritania in 2006 to that in 2007?
Your response must be concise. 1.14. What is the difference between the highest and the second highest Value added (constant 2005 US$) in Central Europe?
Offer a very short reply. 2.00e+1. What is the difference between the highest and the second highest Value added (constant 2005 US$) in Middle East & North Africa (developing only)?
Make the answer very short. 1.70e+1. What is the difference between the highest and the second highest Value added (constant 2005 US$) of Eritrea?
Offer a very short reply. 1.08e+07. What is the difference between the highest and the second highest Value added (constant 2005 US$) in Mauritania?
Offer a terse response. 1.26e+08. What is the difference between the highest and the lowest Value added (constant 2005 US$) in Central Europe?
Provide a succinct answer. 9.36e+1. What is the difference between the highest and the lowest Value added (constant 2005 US$) in Middle East & North Africa (developing only)?
Keep it short and to the point. 6.70e+1. What is the difference between the highest and the lowest Value added (constant 2005 US$) in Eritrea?
Offer a terse response. 5.49e+07. What is the difference between the highest and the lowest Value added (constant 2005 US$) in Mauritania?
Give a very brief answer. 5.39e+08. 